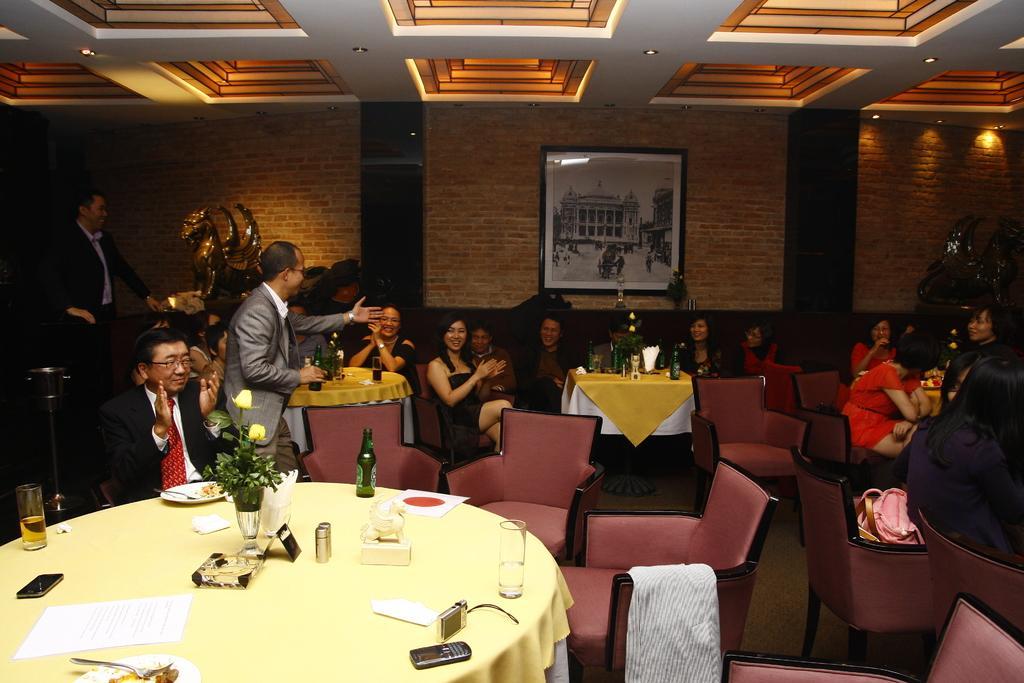Please provide a concise description of this image. In this picture we can see a group of people are sitting on the chairs, and in front here is the table and wine bottle and some objects on it, and here is the wall and photo frame on it, and at above here is the roof. 